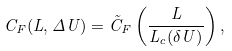Convert formula to latex. <formula><loc_0><loc_0><loc_500><loc_500>C _ { F } ( L , \Delta U ) = \tilde { C } _ { F } \left ( \frac { L } { L _ { c } ( \delta U ) } \right ) ,</formula> 